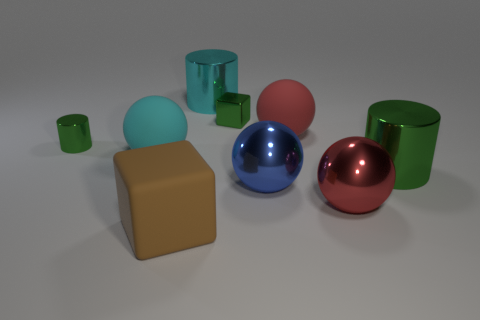Subtract all cyan balls. How many balls are left? 3 Subtract all brown spheres. Subtract all green blocks. How many spheres are left? 4 Add 1 big brown metal cubes. How many objects exist? 10 Subtract all cylinders. How many objects are left? 6 Subtract 1 red balls. How many objects are left? 8 Subtract all big blue matte spheres. Subtract all large cyan things. How many objects are left? 7 Add 4 cylinders. How many cylinders are left? 7 Add 6 big cyan matte things. How many big cyan matte things exist? 7 